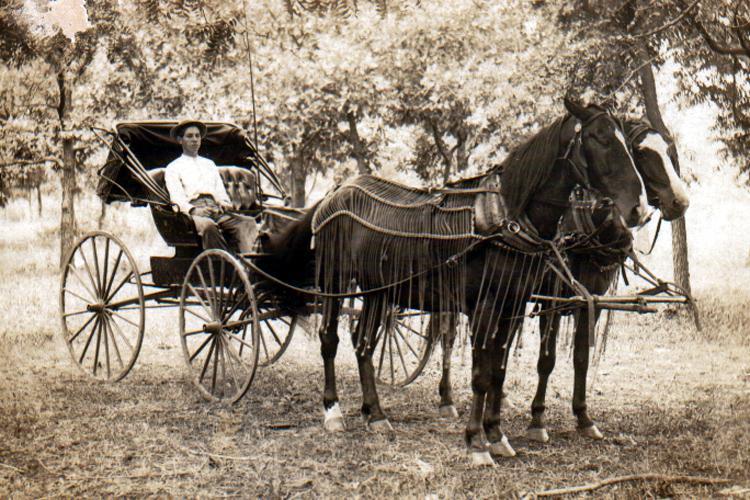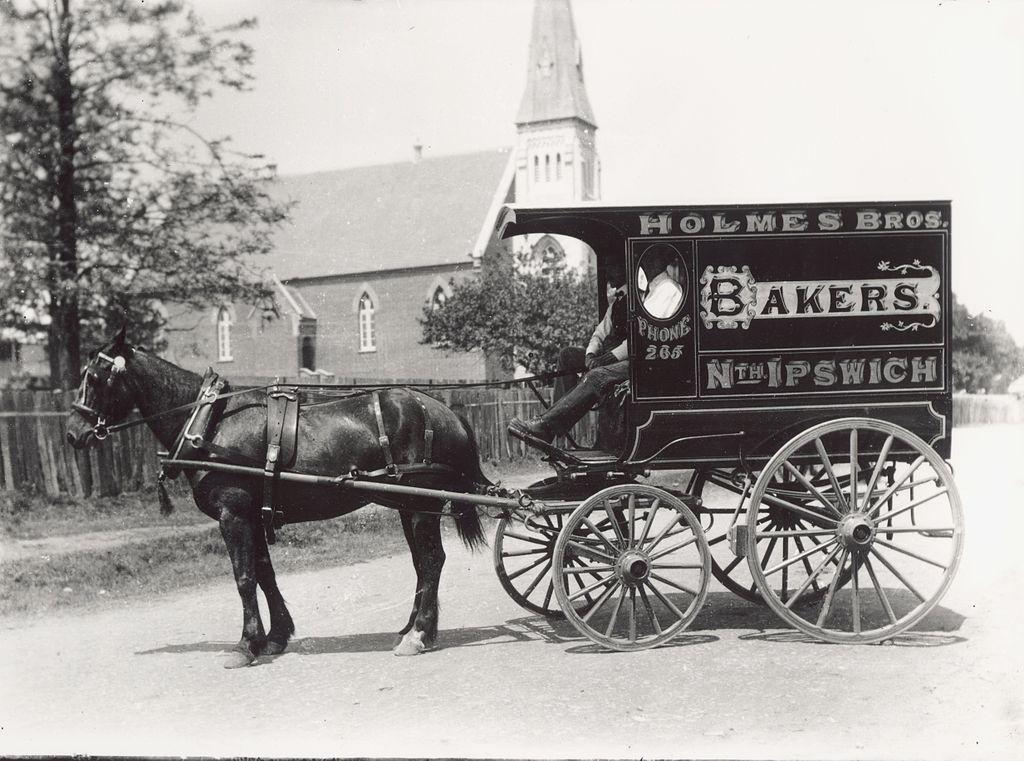The first image is the image on the left, the second image is the image on the right. Examine the images to the left and right. Is the description "There is no color in either image." accurate? Answer yes or no. Yes. The first image is the image on the left, the second image is the image on the right. For the images shown, is this caption "Both images are vintage photos of a carriage." true? Answer yes or no. Yes. 